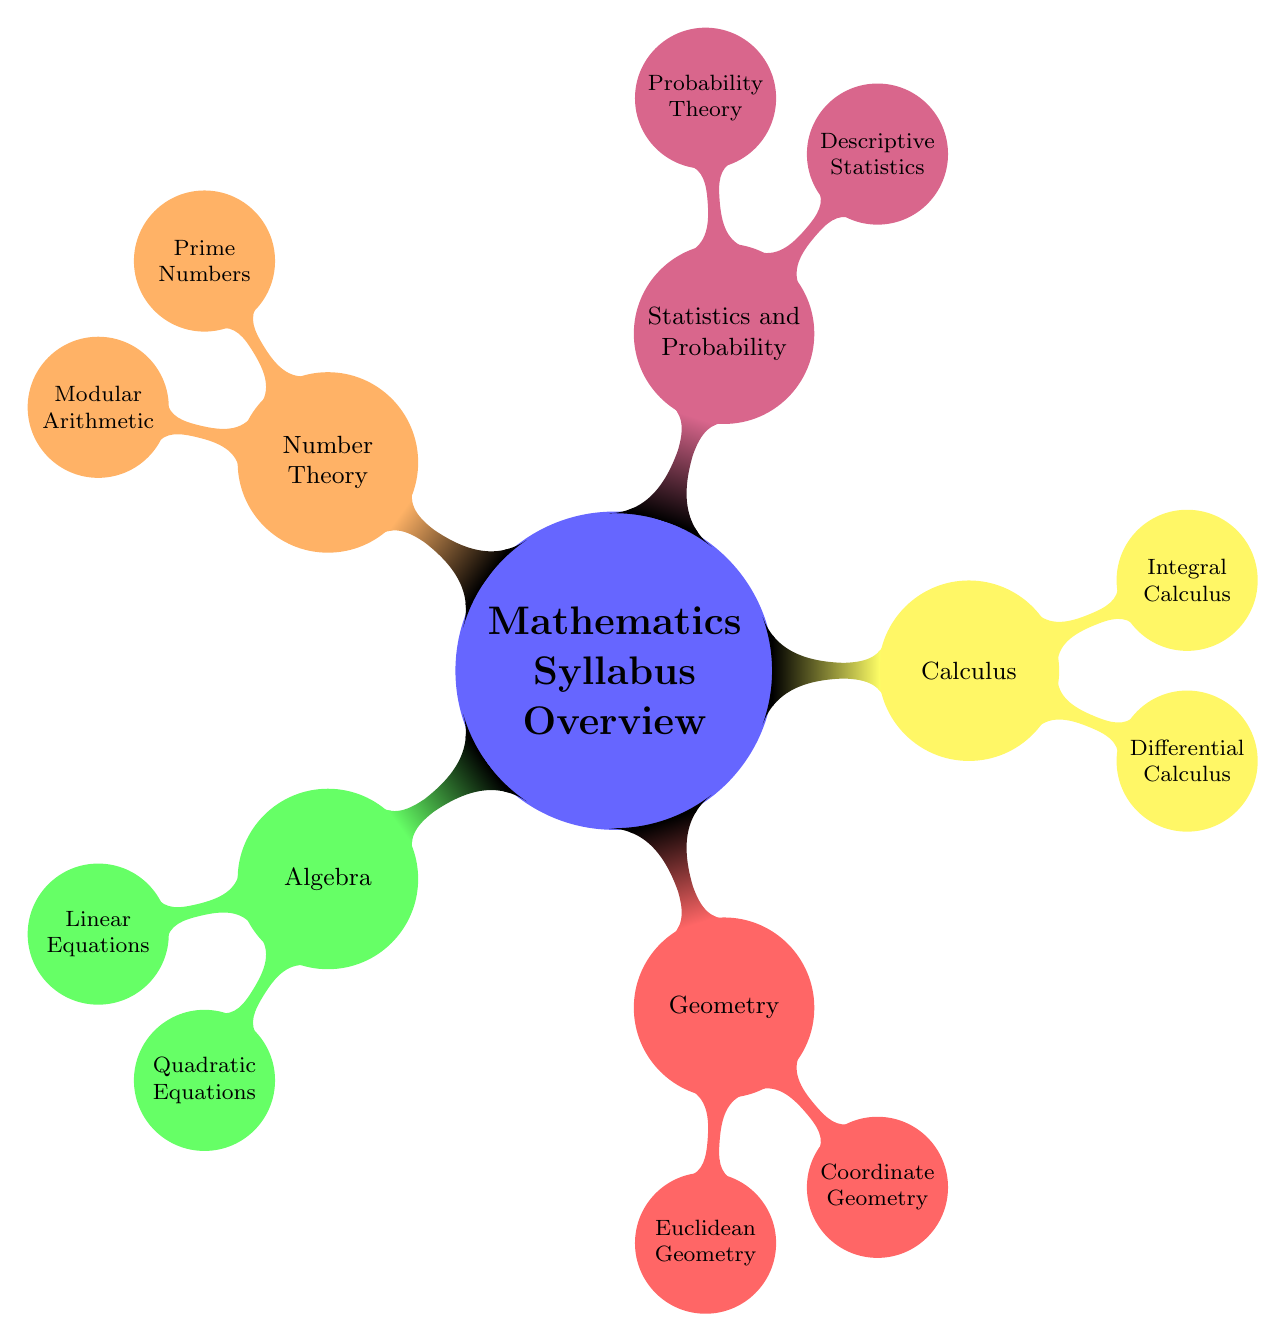What are the main branches of the mathematics syllabus? The main branches of the mathematics syllabus are visible as primary nodes in the diagram, which include Algebra, Geometry, Calculus, Statistics and Probability, and Number Theory.
Answer: Algebra, Geometry, Calculus, Statistics and Probability, Number Theory How many topics are under Calculus? Looking at the Calculus node, it has two child nodes: Differential Calculus and Integral Calculus. Hence, there are two topics listed under Calculus.
Answer: 2 Which branch includes "Modular Arithmetic"? The "Modular Arithmetic" topic is located under the Number Theory branch, as indicated by its placement as a child node of Number Theory in the diagram.
Answer: Number Theory What is the subject of the first child node under Geometry? By examining the Geometry node, the first child node is "Euclidean Geometry," which is its first topic.
Answer: Euclidean Geometry Compare the number of topics in Algebra with those in Statistics and Probability. Algebra has two topics: Linear Equations and Quadratic Equations, while Statistics and Probability has two: Descriptive Statistics and Probability Theory. Therefore, both branches contain the same number of topics, which is two.
Answer: Both have two Which topic under Statistics covers basic concepts? The topic "Descriptive Statistics," which is listed as a child node under Statistics and Probability, covers basic concepts such as measures of central tendency, measures of dispersion, and data visualization.
Answer: Descriptive Statistics What is the relationship between Prime Numbers and Modular Arithmetic? Prime Numbers and Modular Arithmetic are both sub-topics under the Number Theory branch. They are sibling nodes, indicating they share a common parent node (Number Theory) but are separate and distinct topics.
Answer: Sibling nodes Identify the last topic listed under Algebra. Following the linear structure down the Algebra node, the last listed topic appears to be "Quadratic Equations," which is the second child node under Algebra.
Answer: Quadratic Equations 